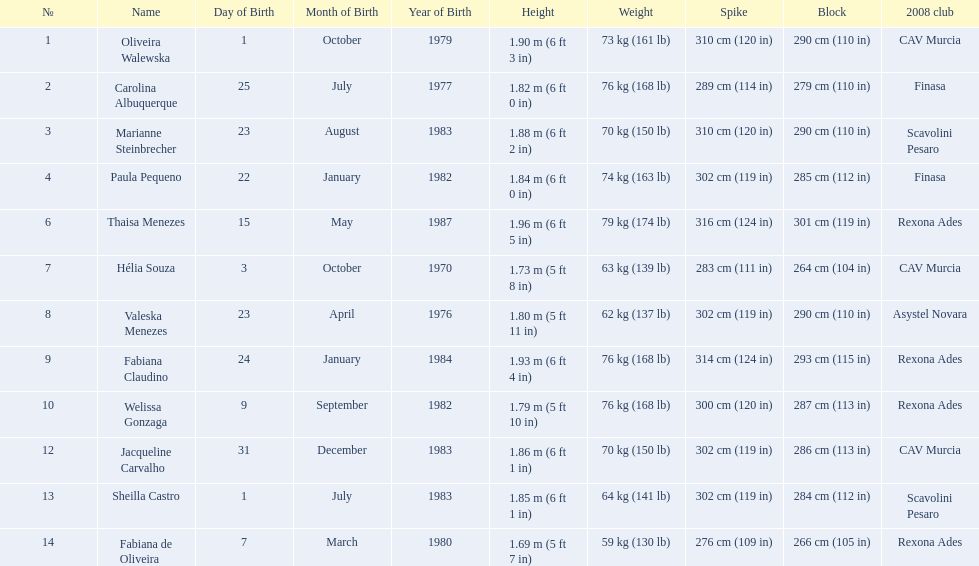What are the heights of the players? 1.90 m (6 ft 3 in), 1.82 m (6 ft 0 in), 1.88 m (6 ft 2 in), 1.84 m (6 ft 0 in), 1.96 m (6 ft 5 in), 1.73 m (5 ft 8 in), 1.80 m (5 ft 11 in), 1.93 m (6 ft 4 in), 1.79 m (5 ft 10 in), 1.86 m (6 ft 1 in), 1.85 m (6 ft 1 in), 1.69 m (5 ft 7 in). Which of these heights is the shortest? 1.69 m (5 ft 7 in). Which player is 5'7 tall? Fabiana de Oliveira. 